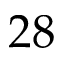<formula> <loc_0><loc_0><loc_500><loc_500>2 8</formula> 